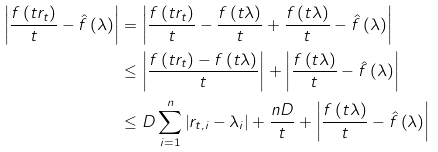<formula> <loc_0><loc_0><loc_500><loc_500>\left | \frac { f \left ( t r _ { t } \right ) } { t } - \hat { f } \left ( \lambda \right ) \right | & = \left | \frac { f \left ( t r _ { t } \right ) } { t } - \frac { f \left ( t \lambda \right ) } { t } + \frac { f \left ( t \lambda \right ) } { t } - \hat { f } \left ( \lambda \right ) \right | \\ & \leq \left | \frac { f \left ( t r _ { t } \right ) - f \left ( t \lambda \right ) } { t } \right | + \left | \frac { f \left ( t \lambda \right ) } { t } - \hat { f } \left ( \lambda \right ) \right | \\ & \leq D \sum _ { i = 1 } ^ { n } \left | r _ { t , i } - \lambda _ { i } \right | + \frac { n D } { t } + \left | \frac { f \left ( t \lambda \right ) } { t } - \hat { f } \left ( \lambda \right ) \right |</formula> 